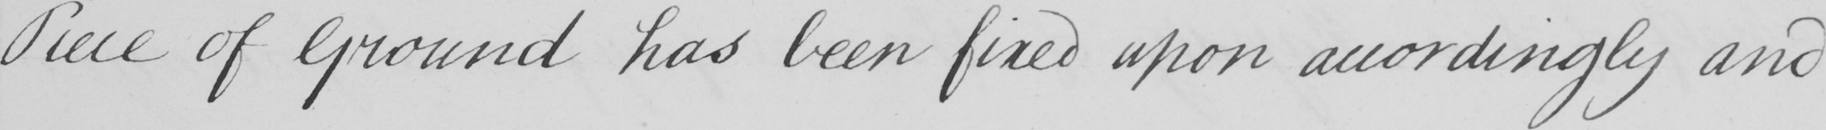What does this handwritten line say? Piece of Ground has been fixed upon accordingly and 